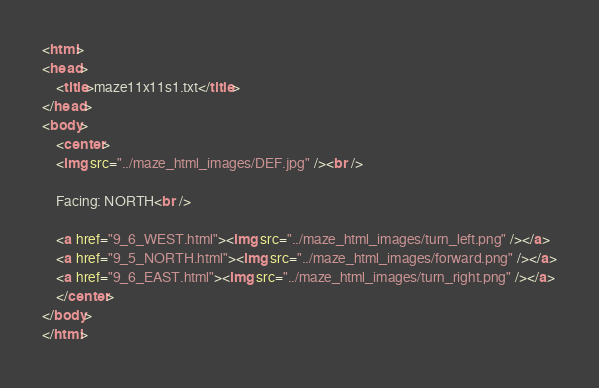Convert code to text. <code><loc_0><loc_0><loc_500><loc_500><_HTML_>
<html>
<head>
    <title>maze11x11s1.txt</title>
</head>
<body>
    <center>
    <img src="../maze_html_images/DEF.jpg" /><br />

    Facing: NORTH<br />

    <a href="9_6_WEST.html"><img src="../maze_html_images/turn_left.png" /></a>
    <a href="9_5_NORTH.html"><img src="../maze_html_images/forward.png" /></a>
    <a href="9_6_EAST.html"><img src="../maze_html_images/turn_right.png" /></a>
    </center>
</body>
</html>
</code> 